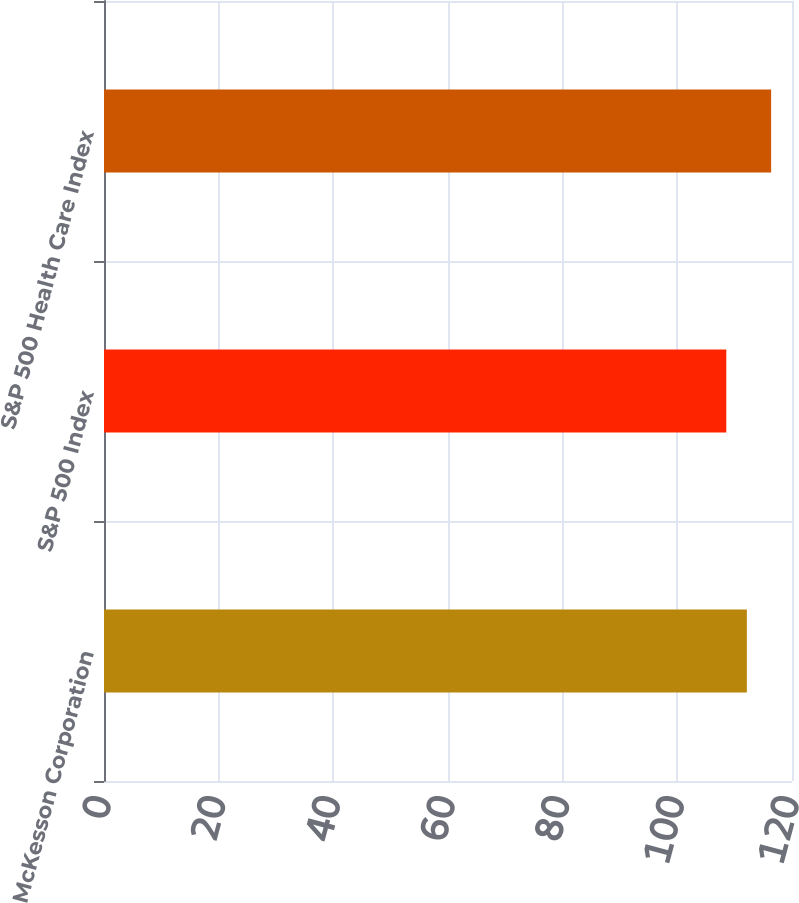Convert chart. <chart><loc_0><loc_0><loc_500><loc_500><bar_chart><fcel>McKesson Corporation<fcel>S&P 500 Index<fcel>S&P 500 Health Care Index<nl><fcel>112.13<fcel>108.54<fcel>116.36<nl></chart> 